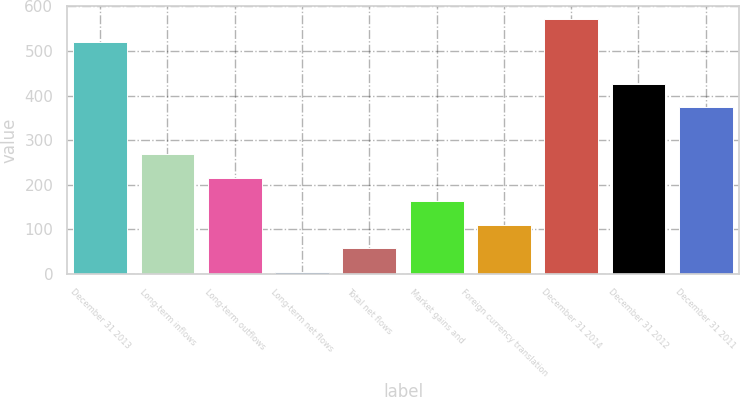Convert chart. <chart><loc_0><loc_0><loc_500><loc_500><bar_chart><fcel>December 31 2013<fcel>Long-term inflows<fcel>Long-term outflows<fcel>Long-term net flows<fcel>Total net flows<fcel>Market gains and<fcel>Foreign currency translation<fcel>December 31 2014<fcel>December 31 2012<fcel>December 31 2011<nl><fcel>519.6<fcel>268.75<fcel>216<fcel>5<fcel>57.75<fcel>163.25<fcel>110.5<fcel>572.35<fcel>426.75<fcel>374<nl></chart> 